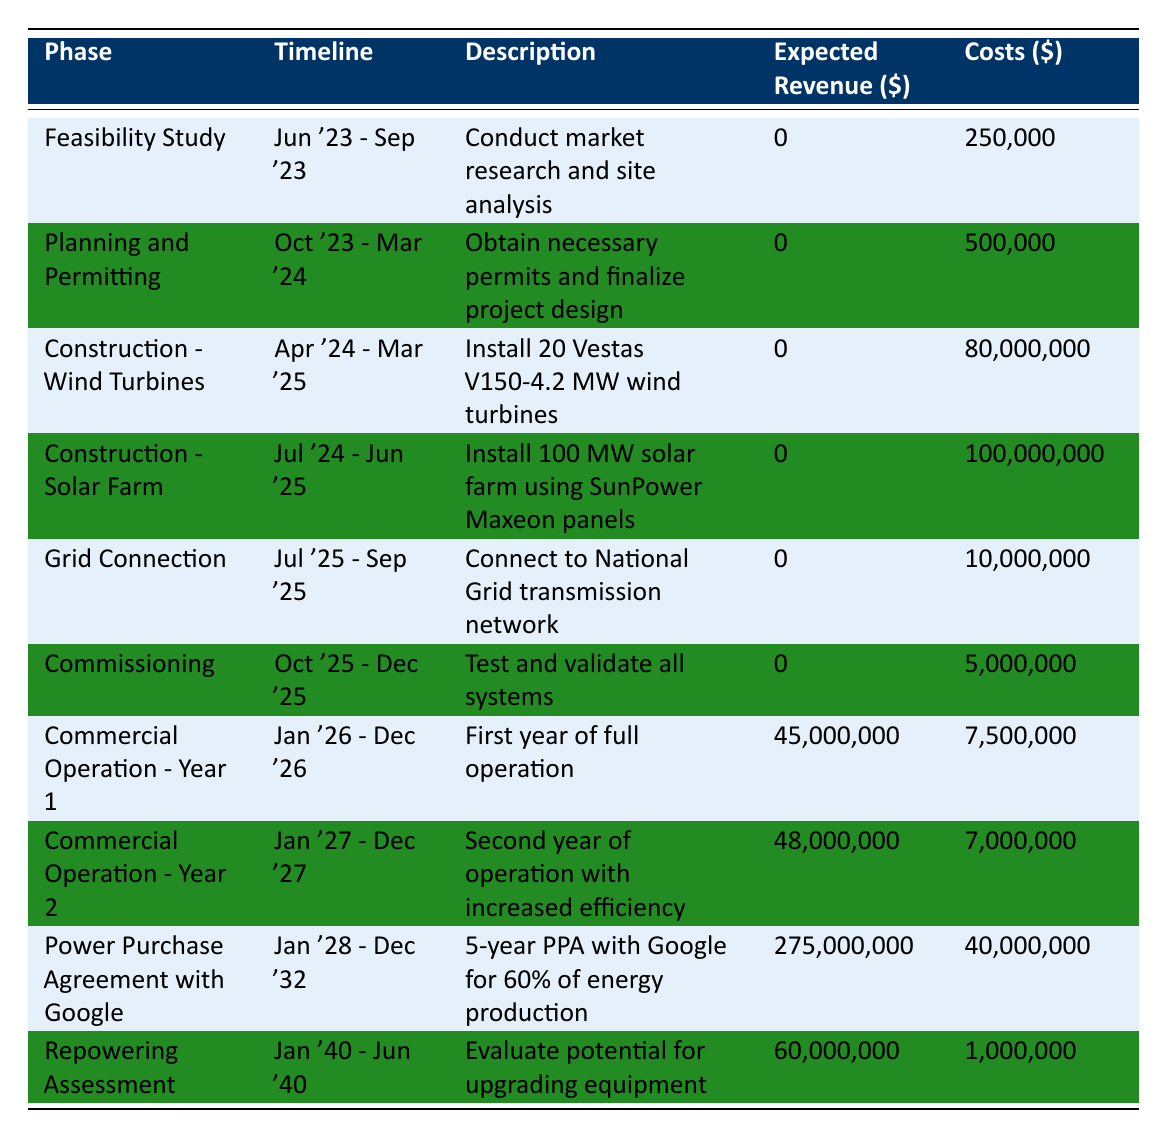What is the expected revenue from the Feasibility Study phase? The expected revenue for the Feasibility Study phase is directly listed in the table under "Expected Revenue," which shows 0.
Answer: 0 During which phase is the construction of wind turbines scheduled to occur? The construction of wind turbines is scheduled during the phase labeled "Construction - Wind Turbines," which is set to occur from April 2024 to March 2025.
Answer: Construction - Wind Turbines What are the total costs for the Planning and Permitting phase and the Grid Connection phase combined? To find the combined costs, add the costs of both phases: Planning and Permitting costs 500,000, and Grid Connection costs 10,000,000. The total is 500,000 + 10,000,000 = 10,500,000.
Answer: 10,500,000 Is it true that the Commercial Operation phase generates revenue? Yes, the table indicates that the Commercial Operation phases do have expected revenues, specifically showing 45,000,000 in Year 1 and 48,000,000 in Year 2.
Answer: Yes What is the total expected revenue across all phases, including the Power Purchase Agreement? To find the total expected revenue, add the expected revenues from each phase: 0 + 0 + 0 + 0 + 0 + 0 + 45,000,000 + 48,000,000 + 275,000,000 + 60,000,000 = 428,000,000.
Answer: 428,000,000 In which phase does the company expect to conduct a Repowering Assessment? The company expects to conduct a Repowering Assessment in the phase named "Repowering Assessment," which runs from January 1, 2040, to June 30, 2040.
Answer: Repowering Assessment What is the difference in expected revenue between Commercial Operation - Year 1 and Commercial Operation - Year 2? The expected revenue for Commercial Operation - Year 1 is 45,000,000, and for Year 2, it is 48,000,000. The difference can be calculated as 48,000,000 - 45,000,000 = 3,000,000.
Answer: 3,000,000 Which phase incurs the highest costs? The phase with the highest costs is "Construction - Solar Farm," which incurs 100,000,000.
Answer: Construction - Solar Farm What is the average expected revenue from the operational phases (Years 1 and 2 and Power Purchase Agreement)? The operational phases have expected revenues of 45,000,000 (Year 1), 48,000,000 (Year 2), and 275,000,000 (PPA). To find the average, add them together (45,000,000 + 48,000,000 + 275,000,000 = 368,000,000) and divide by the number of phases (3), resulting in an average of 368,000,000 / 3 = 122,666,666.67.
Answer: 122,666,666.67 